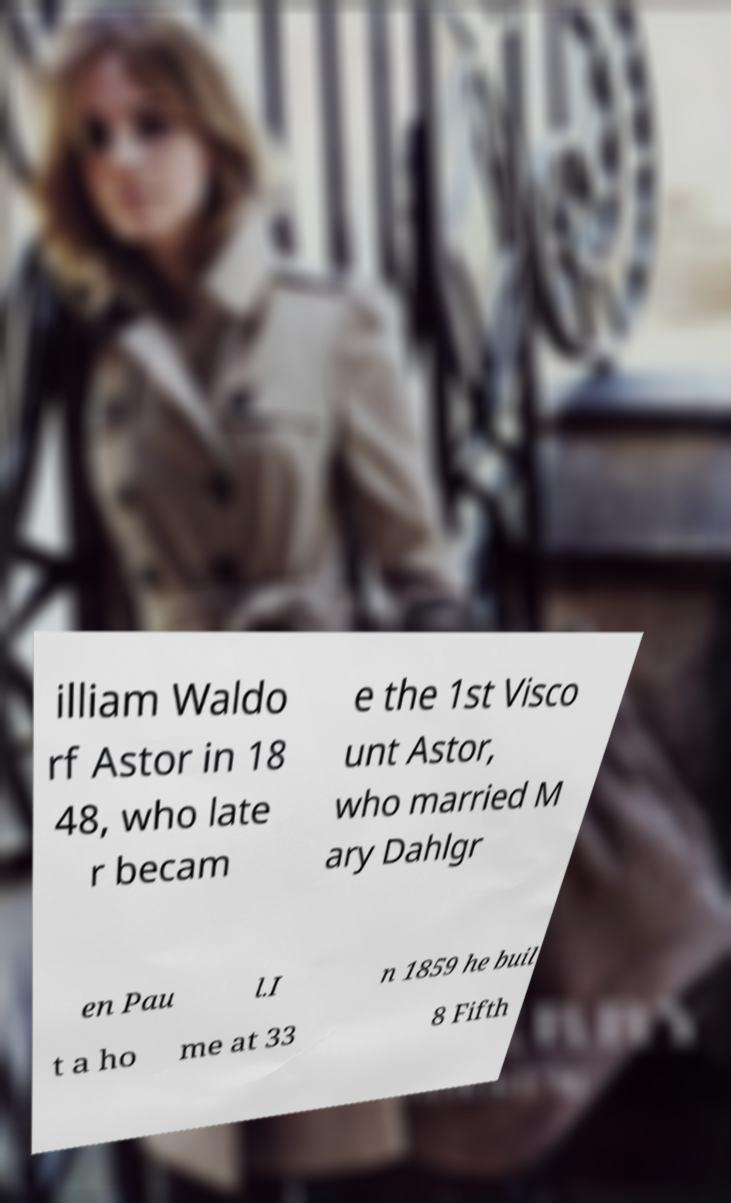Please read and relay the text visible in this image. What does it say? illiam Waldo rf Astor in 18 48, who late r becam e the 1st Visco unt Astor, who married M ary Dahlgr en Pau l.I n 1859 he buil t a ho me at 33 8 Fifth 